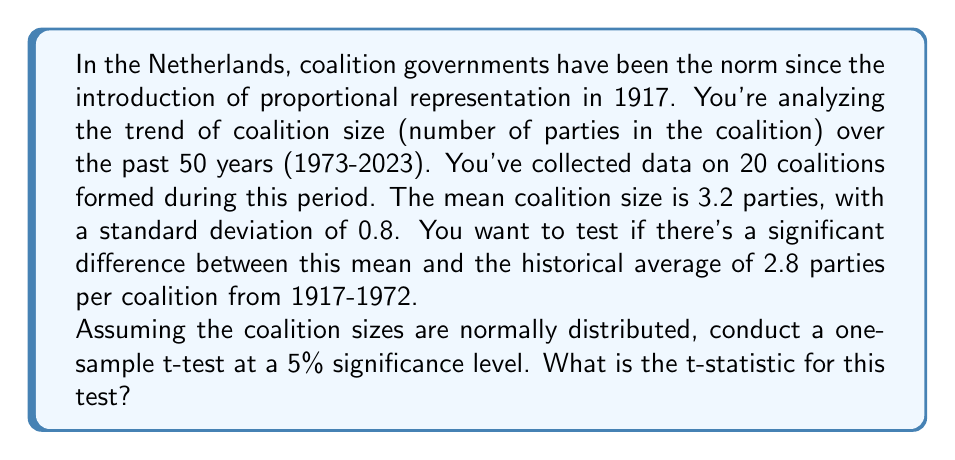Provide a solution to this math problem. To solve this problem, we'll use a one-sample t-test. The steps are as follows:

1) First, let's identify our variables:
   $\bar{x}$ = 3.2 (sample mean)
   $\mu_0$ = 2.8 (historical mean, our null hypothesis)
   $s$ = 0.8 (sample standard deviation)
   $n$ = 20 (sample size)

2) The formula for the t-statistic is:

   $$ t = \frac{\bar{x} - \mu_0}{s / \sqrt{n}} $$

3) Let's substitute our values:

   $$ t = \frac{3.2 - 2.8}{0.8 / \sqrt{20}} $$

4) Simplify the denominator:
   $\sqrt{20} = 4.472$
   $0.8 / 4.472 = 0.179$

   $$ t = \frac{0.4}{0.179} $$

5) Calculate the final result:

   $$ t = 2.235 $$

This t-statistic of 2.235 represents the number of standard deviations our sample mean is from the hypothesized population mean.
Answer: The t-statistic is 2.235. 